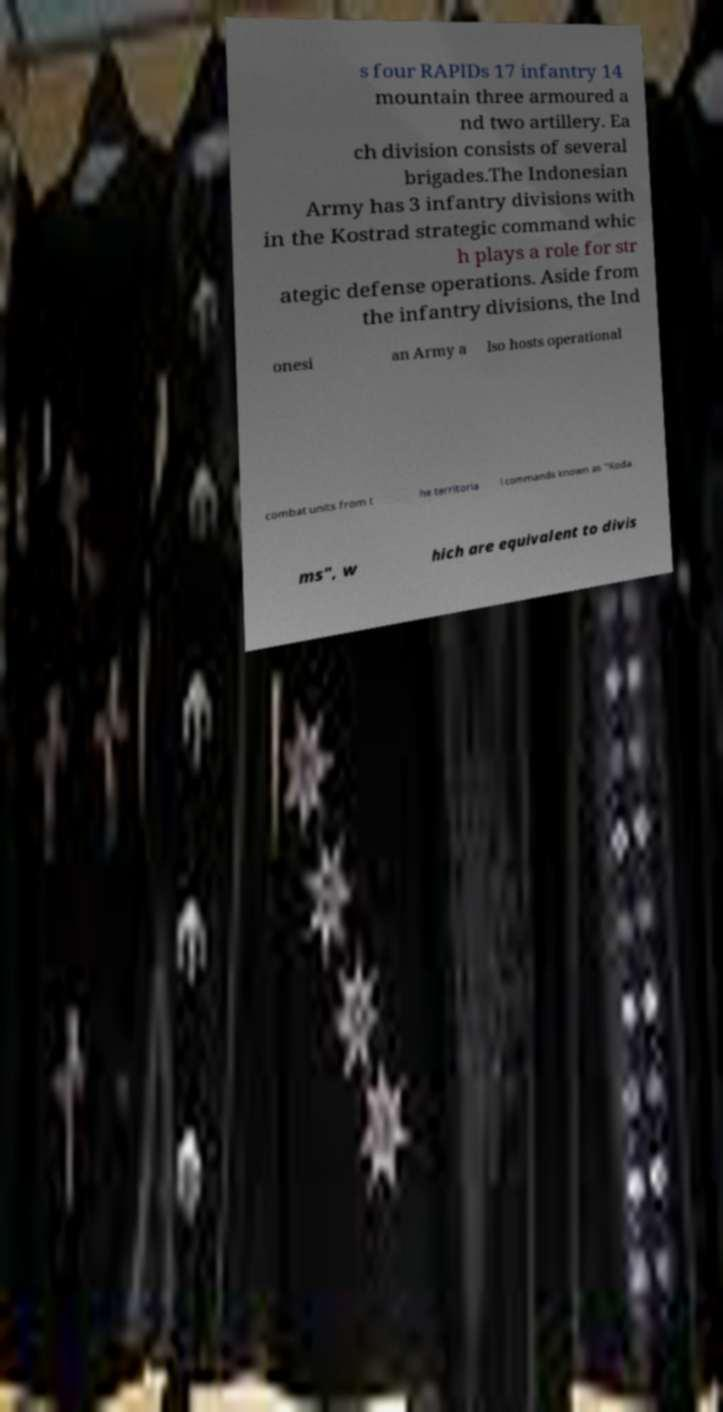Could you assist in decoding the text presented in this image and type it out clearly? s four RAPIDs 17 infantry 14 mountain three armoured a nd two artillery. Ea ch division consists of several brigades.The Indonesian Army has 3 infantry divisions with in the Kostrad strategic command whic h plays a role for str ategic defense operations. Aside from the infantry divisions, the Ind onesi an Army a lso hosts operational combat units from t he territoria l commands known as "Koda ms", w hich are equivalent to divis 